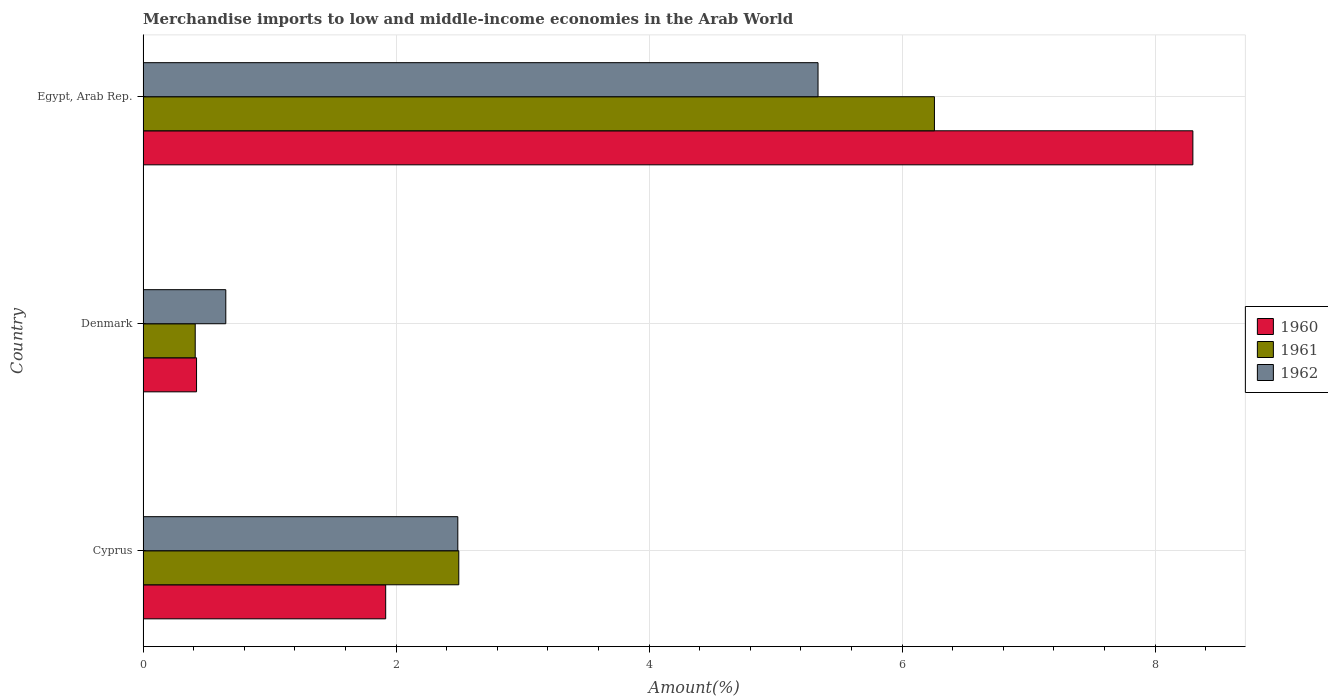Are the number of bars per tick equal to the number of legend labels?
Ensure brevity in your answer.  Yes. Are the number of bars on each tick of the Y-axis equal?
Your response must be concise. Yes. In how many cases, is the number of bars for a given country not equal to the number of legend labels?
Offer a terse response. 0. What is the percentage of amount earned from merchandise imports in 1960 in Egypt, Arab Rep.?
Give a very brief answer. 8.3. Across all countries, what is the maximum percentage of amount earned from merchandise imports in 1962?
Your response must be concise. 5.34. Across all countries, what is the minimum percentage of amount earned from merchandise imports in 1961?
Ensure brevity in your answer.  0.41. In which country was the percentage of amount earned from merchandise imports in 1961 maximum?
Offer a very short reply. Egypt, Arab Rep. What is the total percentage of amount earned from merchandise imports in 1962 in the graph?
Provide a succinct answer. 8.48. What is the difference between the percentage of amount earned from merchandise imports in 1960 in Cyprus and that in Egypt, Arab Rep.?
Give a very brief answer. -6.38. What is the difference between the percentage of amount earned from merchandise imports in 1962 in Denmark and the percentage of amount earned from merchandise imports in 1960 in Egypt, Arab Rep.?
Give a very brief answer. -7.64. What is the average percentage of amount earned from merchandise imports in 1960 per country?
Offer a very short reply. 3.55. What is the difference between the percentage of amount earned from merchandise imports in 1960 and percentage of amount earned from merchandise imports in 1961 in Egypt, Arab Rep.?
Make the answer very short. 2.04. In how many countries, is the percentage of amount earned from merchandise imports in 1960 greater than 0.4 %?
Ensure brevity in your answer.  3. What is the ratio of the percentage of amount earned from merchandise imports in 1962 in Denmark to that in Egypt, Arab Rep.?
Give a very brief answer. 0.12. Is the percentage of amount earned from merchandise imports in 1962 in Cyprus less than that in Egypt, Arab Rep.?
Provide a short and direct response. Yes. What is the difference between the highest and the second highest percentage of amount earned from merchandise imports in 1962?
Give a very brief answer. 2.85. What is the difference between the highest and the lowest percentage of amount earned from merchandise imports in 1960?
Offer a very short reply. 7.88. In how many countries, is the percentage of amount earned from merchandise imports in 1960 greater than the average percentage of amount earned from merchandise imports in 1960 taken over all countries?
Your answer should be compact. 1. Is the sum of the percentage of amount earned from merchandise imports in 1962 in Denmark and Egypt, Arab Rep. greater than the maximum percentage of amount earned from merchandise imports in 1960 across all countries?
Your answer should be compact. No. Are all the bars in the graph horizontal?
Offer a very short reply. Yes. Are the values on the major ticks of X-axis written in scientific E-notation?
Your answer should be very brief. No. Does the graph contain grids?
Your response must be concise. Yes. Where does the legend appear in the graph?
Provide a short and direct response. Center right. How are the legend labels stacked?
Your answer should be compact. Vertical. What is the title of the graph?
Your answer should be compact. Merchandise imports to low and middle-income economies in the Arab World. Does "1970" appear as one of the legend labels in the graph?
Provide a short and direct response. No. What is the label or title of the X-axis?
Offer a very short reply. Amount(%). What is the label or title of the Y-axis?
Make the answer very short. Country. What is the Amount(%) in 1960 in Cyprus?
Make the answer very short. 1.92. What is the Amount(%) of 1961 in Cyprus?
Keep it short and to the point. 2.5. What is the Amount(%) in 1962 in Cyprus?
Offer a very short reply. 2.49. What is the Amount(%) of 1960 in Denmark?
Offer a very short reply. 0.42. What is the Amount(%) in 1961 in Denmark?
Keep it short and to the point. 0.41. What is the Amount(%) of 1962 in Denmark?
Offer a very short reply. 0.65. What is the Amount(%) of 1960 in Egypt, Arab Rep.?
Offer a terse response. 8.3. What is the Amount(%) of 1961 in Egypt, Arab Rep.?
Your response must be concise. 6.26. What is the Amount(%) in 1962 in Egypt, Arab Rep.?
Your answer should be very brief. 5.34. Across all countries, what is the maximum Amount(%) in 1960?
Keep it short and to the point. 8.3. Across all countries, what is the maximum Amount(%) of 1961?
Make the answer very short. 6.26. Across all countries, what is the maximum Amount(%) of 1962?
Offer a very short reply. 5.34. Across all countries, what is the minimum Amount(%) of 1960?
Give a very brief answer. 0.42. Across all countries, what is the minimum Amount(%) in 1961?
Your answer should be compact. 0.41. Across all countries, what is the minimum Amount(%) of 1962?
Offer a terse response. 0.65. What is the total Amount(%) in 1960 in the graph?
Offer a very short reply. 10.64. What is the total Amount(%) of 1961 in the graph?
Your answer should be compact. 9.16. What is the total Amount(%) in 1962 in the graph?
Make the answer very short. 8.48. What is the difference between the Amount(%) in 1960 in Cyprus and that in Denmark?
Your response must be concise. 1.5. What is the difference between the Amount(%) in 1961 in Cyprus and that in Denmark?
Your answer should be compact. 2.08. What is the difference between the Amount(%) in 1962 in Cyprus and that in Denmark?
Your response must be concise. 1.83. What is the difference between the Amount(%) in 1960 in Cyprus and that in Egypt, Arab Rep.?
Give a very brief answer. -6.38. What is the difference between the Amount(%) of 1961 in Cyprus and that in Egypt, Arab Rep.?
Offer a very short reply. -3.76. What is the difference between the Amount(%) of 1962 in Cyprus and that in Egypt, Arab Rep.?
Keep it short and to the point. -2.85. What is the difference between the Amount(%) of 1960 in Denmark and that in Egypt, Arab Rep.?
Give a very brief answer. -7.88. What is the difference between the Amount(%) in 1961 in Denmark and that in Egypt, Arab Rep.?
Make the answer very short. -5.84. What is the difference between the Amount(%) in 1962 in Denmark and that in Egypt, Arab Rep.?
Your answer should be compact. -4.68. What is the difference between the Amount(%) in 1960 in Cyprus and the Amount(%) in 1961 in Denmark?
Give a very brief answer. 1.51. What is the difference between the Amount(%) of 1960 in Cyprus and the Amount(%) of 1962 in Denmark?
Provide a succinct answer. 1.26. What is the difference between the Amount(%) of 1961 in Cyprus and the Amount(%) of 1962 in Denmark?
Ensure brevity in your answer.  1.84. What is the difference between the Amount(%) in 1960 in Cyprus and the Amount(%) in 1961 in Egypt, Arab Rep.?
Make the answer very short. -4.34. What is the difference between the Amount(%) in 1960 in Cyprus and the Amount(%) in 1962 in Egypt, Arab Rep.?
Your answer should be very brief. -3.42. What is the difference between the Amount(%) in 1961 in Cyprus and the Amount(%) in 1962 in Egypt, Arab Rep.?
Keep it short and to the point. -2.84. What is the difference between the Amount(%) in 1960 in Denmark and the Amount(%) in 1961 in Egypt, Arab Rep.?
Your response must be concise. -5.83. What is the difference between the Amount(%) of 1960 in Denmark and the Amount(%) of 1962 in Egypt, Arab Rep.?
Ensure brevity in your answer.  -4.91. What is the difference between the Amount(%) of 1961 in Denmark and the Amount(%) of 1962 in Egypt, Arab Rep.?
Provide a succinct answer. -4.92. What is the average Amount(%) in 1960 per country?
Offer a very short reply. 3.55. What is the average Amount(%) in 1961 per country?
Offer a terse response. 3.05. What is the average Amount(%) in 1962 per country?
Keep it short and to the point. 2.83. What is the difference between the Amount(%) of 1960 and Amount(%) of 1961 in Cyprus?
Offer a very short reply. -0.58. What is the difference between the Amount(%) of 1960 and Amount(%) of 1962 in Cyprus?
Ensure brevity in your answer.  -0.57. What is the difference between the Amount(%) in 1961 and Amount(%) in 1962 in Cyprus?
Offer a very short reply. 0.01. What is the difference between the Amount(%) in 1960 and Amount(%) in 1961 in Denmark?
Make the answer very short. 0.01. What is the difference between the Amount(%) of 1960 and Amount(%) of 1962 in Denmark?
Make the answer very short. -0.23. What is the difference between the Amount(%) of 1961 and Amount(%) of 1962 in Denmark?
Offer a terse response. -0.24. What is the difference between the Amount(%) of 1960 and Amount(%) of 1961 in Egypt, Arab Rep.?
Ensure brevity in your answer.  2.04. What is the difference between the Amount(%) of 1960 and Amount(%) of 1962 in Egypt, Arab Rep.?
Make the answer very short. 2.96. What is the difference between the Amount(%) in 1961 and Amount(%) in 1962 in Egypt, Arab Rep.?
Your answer should be very brief. 0.92. What is the ratio of the Amount(%) in 1960 in Cyprus to that in Denmark?
Provide a short and direct response. 4.54. What is the ratio of the Amount(%) in 1961 in Cyprus to that in Denmark?
Make the answer very short. 6.05. What is the ratio of the Amount(%) of 1962 in Cyprus to that in Denmark?
Give a very brief answer. 3.8. What is the ratio of the Amount(%) of 1960 in Cyprus to that in Egypt, Arab Rep.?
Give a very brief answer. 0.23. What is the ratio of the Amount(%) in 1961 in Cyprus to that in Egypt, Arab Rep.?
Your answer should be very brief. 0.4. What is the ratio of the Amount(%) in 1962 in Cyprus to that in Egypt, Arab Rep.?
Provide a short and direct response. 0.47. What is the ratio of the Amount(%) of 1960 in Denmark to that in Egypt, Arab Rep.?
Provide a succinct answer. 0.05. What is the ratio of the Amount(%) of 1961 in Denmark to that in Egypt, Arab Rep.?
Provide a succinct answer. 0.07. What is the ratio of the Amount(%) in 1962 in Denmark to that in Egypt, Arab Rep.?
Your answer should be compact. 0.12. What is the difference between the highest and the second highest Amount(%) in 1960?
Make the answer very short. 6.38. What is the difference between the highest and the second highest Amount(%) in 1961?
Your answer should be compact. 3.76. What is the difference between the highest and the second highest Amount(%) in 1962?
Offer a very short reply. 2.85. What is the difference between the highest and the lowest Amount(%) of 1960?
Offer a very short reply. 7.88. What is the difference between the highest and the lowest Amount(%) of 1961?
Your answer should be compact. 5.84. What is the difference between the highest and the lowest Amount(%) of 1962?
Your response must be concise. 4.68. 